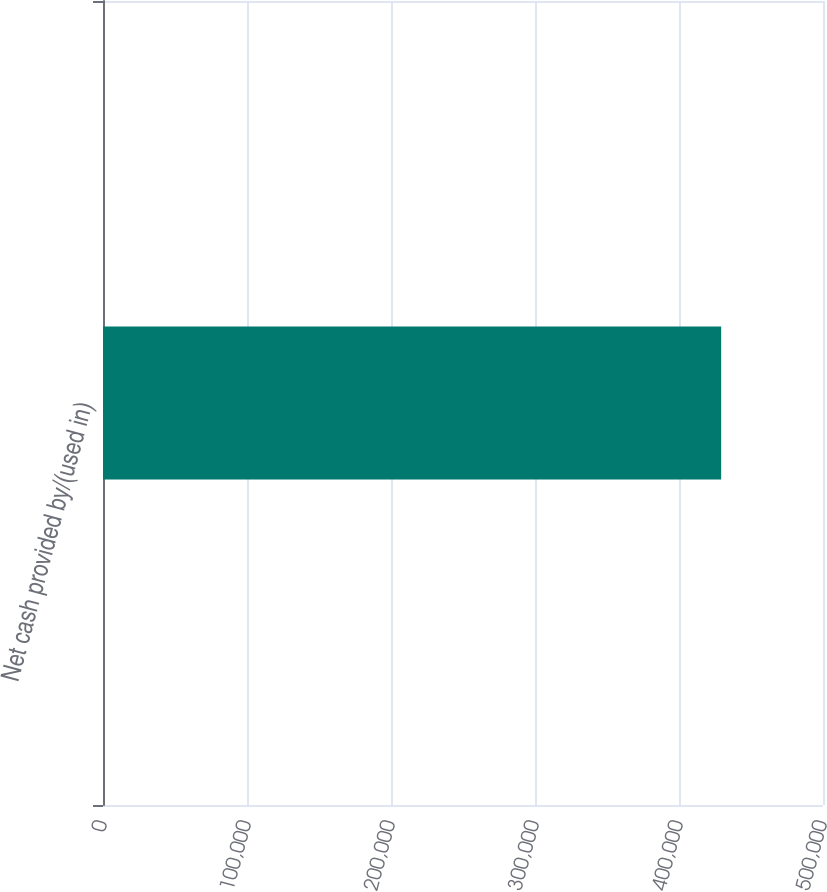<chart> <loc_0><loc_0><loc_500><loc_500><bar_chart><fcel>Net cash provided by/(used in)<nl><fcel>429282<nl></chart> 